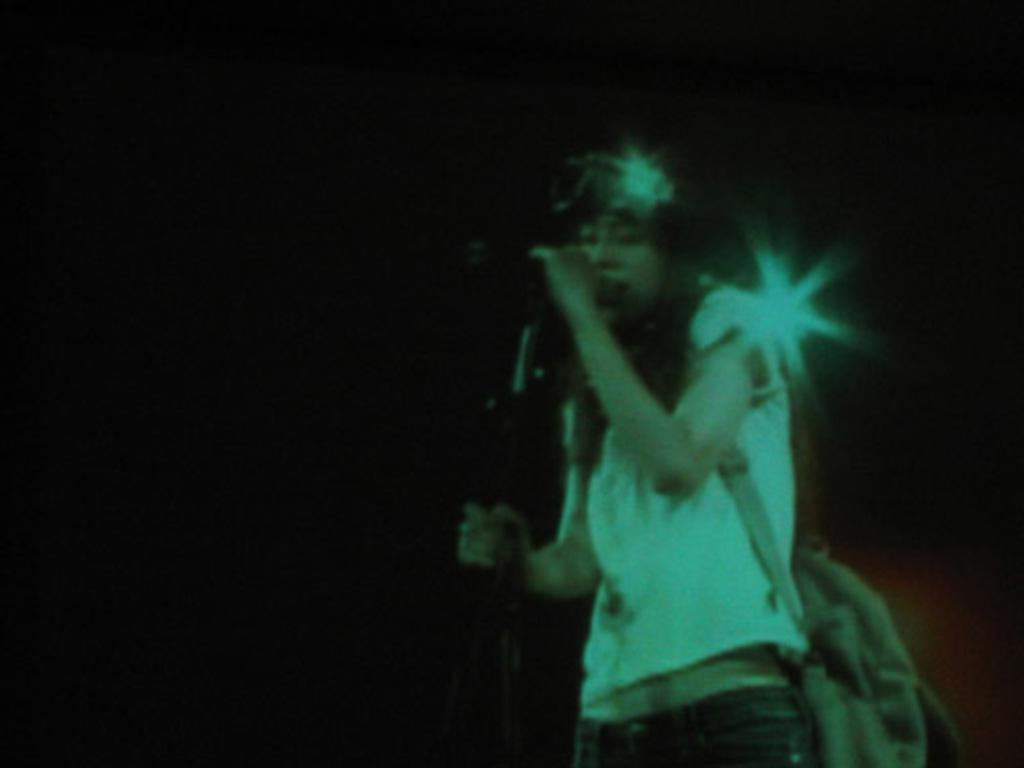Who is the main subject in the image? There is a woman in the image. Where is the woman positioned in the image? The woman is standing on the right side of the image. What is the woman holding in the image? The woman is holding a microphone (Mic) and a backpack. What type of fish can be seen swimming in the middle of the image? There is no fish present in the image; it features a woman holding a microphone and a backpack. What kind of toys can be seen on the left side of the image? There are no toys visible in the image; it only shows a woman standing on the right side with a microphone and a backpack. 